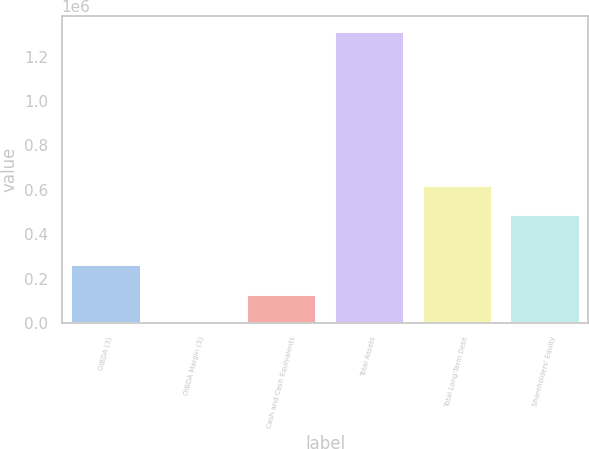Convert chart to OTSL. <chart><loc_0><loc_0><loc_500><loc_500><bar_chart><fcel>OIBDA (3)<fcel>OIBDA Margin (3)<fcel>Cash and Cash Equivalents<fcel>Total Assets<fcel>Total Long-Term Debt<fcel>Shareholders' Equity<nl><fcel>263462<fcel>24.4<fcel>131743<fcel>1.31721e+06<fcel>620473<fcel>488754<nl></chart> 